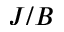<formula> <loc_0><loc_0><loc_500><loc_500>J / B</formula> 